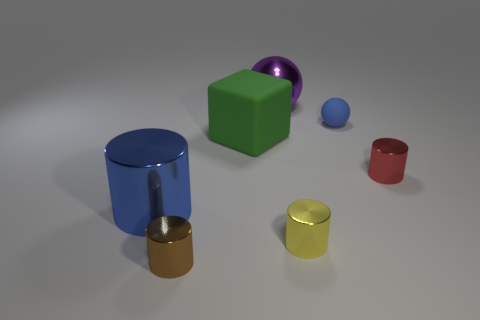Subtract all yellow cylinders. How many cylinders are left? 3 Subtract all large cylinders. How many cylinders are left? 3 Add 1 large brown metal cubes. How many objects exist? 8 Subtract all purple cylinders. Subtract all blue cubes. How many cylinders are left? 4 Subtract all cylinders. How many objects are left? 3 Add 2 brown metallic cylinders. How many brown metallic cylinders exist? 3 Subtract 0 cyan cylinders. How many objects are left? 7 Subtract all large objects. Subtract all big purple things. How many objects are left? 3 Add 1 blue metallic things. How many blue metallic things are left? 2 